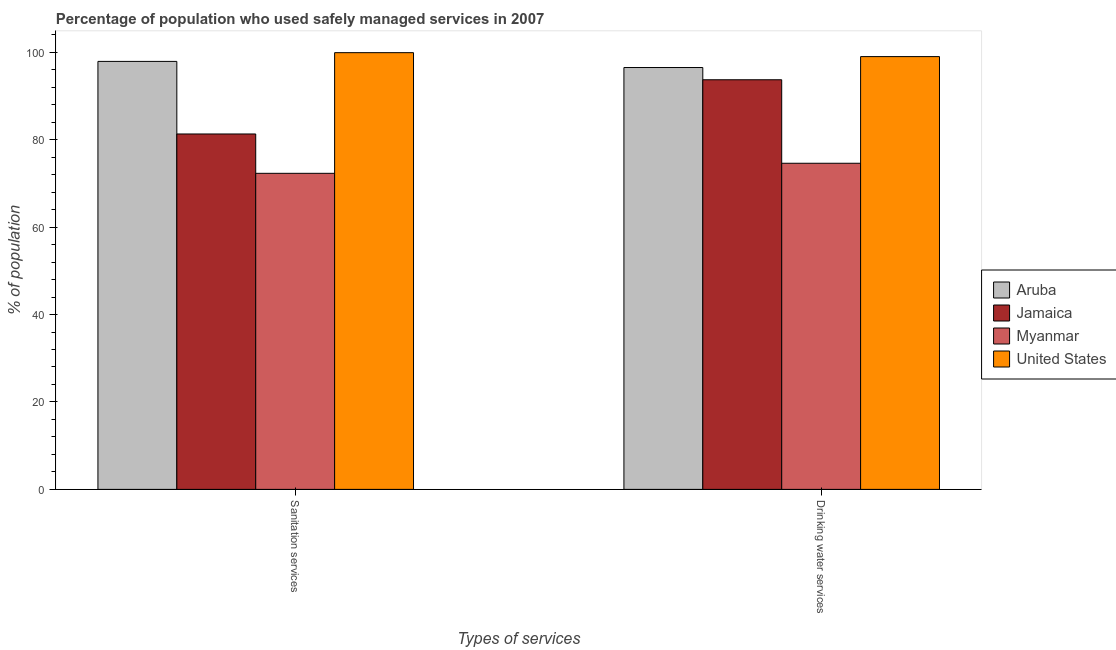How many different coloured bars are there?
Make the answer very short. 4. Are the number of bars per tick equal to the number of legend labels?
Provide a short and direct response. Yes. Are the number of bars on each tick of the X-axis equal?
Ensure brevity in your answer.  Yes. How many bars are there on the 1st tick from the left?
Make the answer very short. 4. What is the label of the 1st group of bars from the left?
Keep it short and to the point. Sanitation services. Across all countries, what is the minimum percentage of population who used sanitation services?
Ensure brevity in your answer.  72.3. In which country was the percentage of population who used drinking water services minimum?
Keep it short and to the point. Myanmar. What is the total percentage of population who used drinking water services in the graph?
Offer a very short reply. 363.8. What is the difference between the percentage of population who used sanitation services in Myanmar and the percentage of population who used drinking water services in Aruba?
Provide a short and direct response. -24.2. What is the average percentage of population who used drinking water services per country?
Provide a succinct answer. 90.95. What is the difference between the percentage of population who used drinking water services and percentage of population who used sanitation services in Jamaica?
Keep it short and to the point. 12.4. What is the ratio of the percentage of population who used sanitation services in United States to that in Aruba?
Your answer should be compact. 1.02. Is the percentage of population who used drinking water services in Aruba less than that in Jamaica?
Your answer should be compact. No. In how many countries, is the percentage of population who used drinking water services greater than the average percentage of population who used drinking water services taken over all countries?
Give a very brief answer. 3. What does the 4th bar from the left in Sanitation services represents?
Give a very brief answer. United States. What does the 2nd bar from the right in Drinking water services represents?
Your response must be concise. Myanmar. How many countries are there in the graph?
Provide a short and direct response. 4. What is the difference between two consecutive major ticks on the Y-axis?
Your answer should be compact. 20. Are the values on the major ticks of Y-axis written in scientific E-notation?
Give a very brief answer. No. Does the graph contain grids?
Give a very brief answer. No. How many legend labels are there?
Make the answer very short. 4. What is the title of the graph?
Make the answer very short. Percentage of population who used safely managed services in 2007. What is the label or title of the X-axis?
Your response must be concise. Types of services. What is the label or title of the Y-axis?
Your response must be concise. % of population. What is the % of population in Aruba in Sanitation services?
Offer a terse response. 97.9. What is the % of population of Jamaica in Sanitation services?
Your answer should be very brief. 81.3. What is the % of population in Myanmar in Sanitation services?
Give a very brief answer. 72.3. What is the % of population of United States in Sanitation services?
Make the answer very short. 99.9. What is the % of population in Aruba in Drinking water services?
Your response must be concise. 96.5. What is the % of population of Jamaica in Drinking water services?
Your answer should be very brief. 93.7. What is the % of population of Myanmar in Drinking water services?
Provide a short and direct response. 74.6. What is the % of population of United States in Drinking water services?
Keep it short and to the point. 99. Across all Types of services, what is the maximum % of population of Aruba?
Provide a short and direct response. 97.9. Across all Types of services, what is the maximum % of population of Jamaica?
Offer a terse response. 93.7. Across all Types of services, what is the maximum % of population of Myanmar?
Your response must be concise. 74.6. Across all Types of services, what is the maximum % of population in United States?
Provide a short and direct response. 99.9. Across all Types of services, what is the minimum % of population of Aruba?
Keep it short and to the point. 96.5. Across all Types of services, what is the minimum % of population of Jamaica?
Offer a terse response. 81.3. Across all Types of services, what is the minimum % of population of Myanmar?
Offer a very short reply. 72.3. Across all Types of services, what is the minimum % of population in United States?
Your answer should be compact. 99. What is the total % of population of Aruba in the graph?
Give a very brief answer. 194.4. What is the total % of population in Jamaica in the graph?
Keep it short and to the point. 175. What is the total % of population in Myanmar in the graph?
Make the answer very short. 146.9. What is the total % of population in United States in the graph?
Offer a very short reply. 198.9. What is the difference between the % of population in Jamaica in Sanitation services and that in Drinking water services?
Offer a terse response. -12.4. What is the difference between the % of population in United States in Sanitation services and that in Drinking water services?
Your response must be concise. 0.9. What is the difference between the % of population in Aruba in Sanitation services and the % of population in Jamaica in Drinking water services?
Ensure brevity in your answer.  4.2. What is the difference between the % of population of Aruba in Sanitation services and the % of population of Myanmar in Drinking water services?
Keep it short and to the point. 23.3. What is the difference between the % of population of Jamaica in Sanitation services and the % of population of United States in Drinking water services?
Your answer should be compact. -17.7. What is the difference between the % of population of Myanmar in Sanitation services and the % of population of United States in Drinking water services?
Make the answer very short. -26.7. What is the average % of population of Aruba per Types of services?
Your response must be concise. 97.2. What is the average % of population in Jamaica per Types of services?
Provide a short and direct response. 87.5. What is the average % of population in Myanmar per Types of services?
Keep it short and to the point. 73.45. What is the average % of population of United States per Types of services?
Your answer should be compact. 99.45. What is the difference between the % of population of Aruba and % of population of Myanmar in Sanitation services?
Your answer should be very brief. 25.6. What is the difference between the % of population in Aruba and % of population in United States in Sanitation services?
Offer a very short reply. -2. What is the difference between the % of population in Jamaica and % of population in United States in Sanitation services?
Offer a terse response. -18.6. What is the difference between the % of population of Myanmar and % of population of United States in Sanitation services?
Your answer should be very brief. -27.6. What is the difference between the % of population of Aruba and % of population of Jamaica in Drinking water services?
Provide a succinct answer. 2.8. What is the difference between the % of population of Aruba and % of population of Myanmar in Drinking water services?
Ensure brevity in your answer.  21.9. What is the difference between the % of population in Aruba and % of population in United States in Drinking water services?
Offer a very short reply. -2.5. What is the difference between the % of population of Jamaica and % of population of Myanmar in Drinking water services?
Offer a terse response. 19.1. What is the difference between the % of population of Jamaica and % of population of United States in Drinking water services?
Give a very brief answer. -5.3. What is the difference between the % of population of Myanmar and % of population of United States in Drinking water services?
Your answer should be very brief. -24.4. What is the ratio of the % of population of Aruba in Sanitation services to that in Drinking water services?
Your answer should be very brief. 1.01. What is the ratio of the % of population in Jamaica in Sanitation services to that in Drinking water services?
Your answer should be compact. 0.87. What is the ratio of the % of population in Myanmar in Sanitation services to that in Drinking water services?
Your answer should be compact. 0.97. What is the ratio of the % of population in United States in Sanitation services to that in Drinking water services?
Offer a terse response. 1.01. What is the difference between the highest and the second highest % of population in Myanmar?
Your answer should be very brief. 2.3. What is the difference between the highest and the second highest % of population in United States?
Keep it short and to the point. 0.9. What is the difference between the highest and the lowest % of population of Aruba?
Your answer should be very brief. 1.4. What is the difference between the highest and the lowest % of population in Jamaica?
Ensure brevity in your answer.  12.4. What is the difference between the highest and the lowest % of population in Myanmar?
Offer a very short reply. 2.3. What is the difference between the highest and the lowest % of population in United States?
Offer a very short reply. 0.9. 